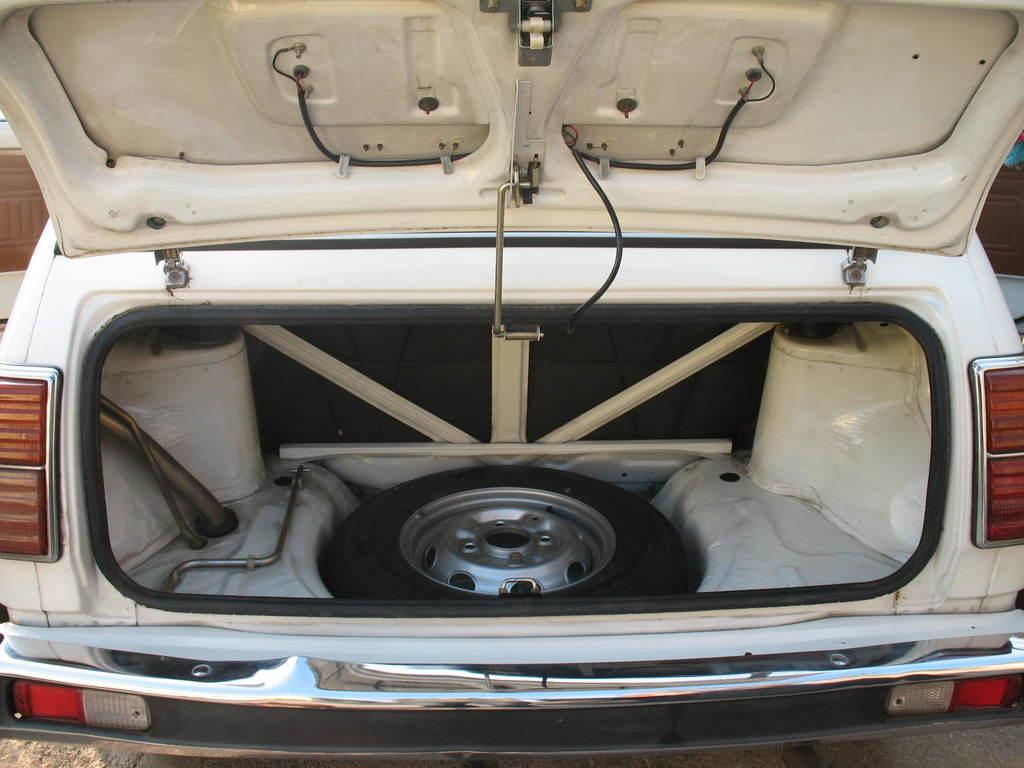What type of vehicle is in the image? There is a white vehicle in the image. What part of the vehicle can be seen in the image? A tire and a rod are visible in the vehicle. What type of reward is being offered to the eggs in the mitten in the image? There is no mention of eggs, a mitten, or a reward in the image. 